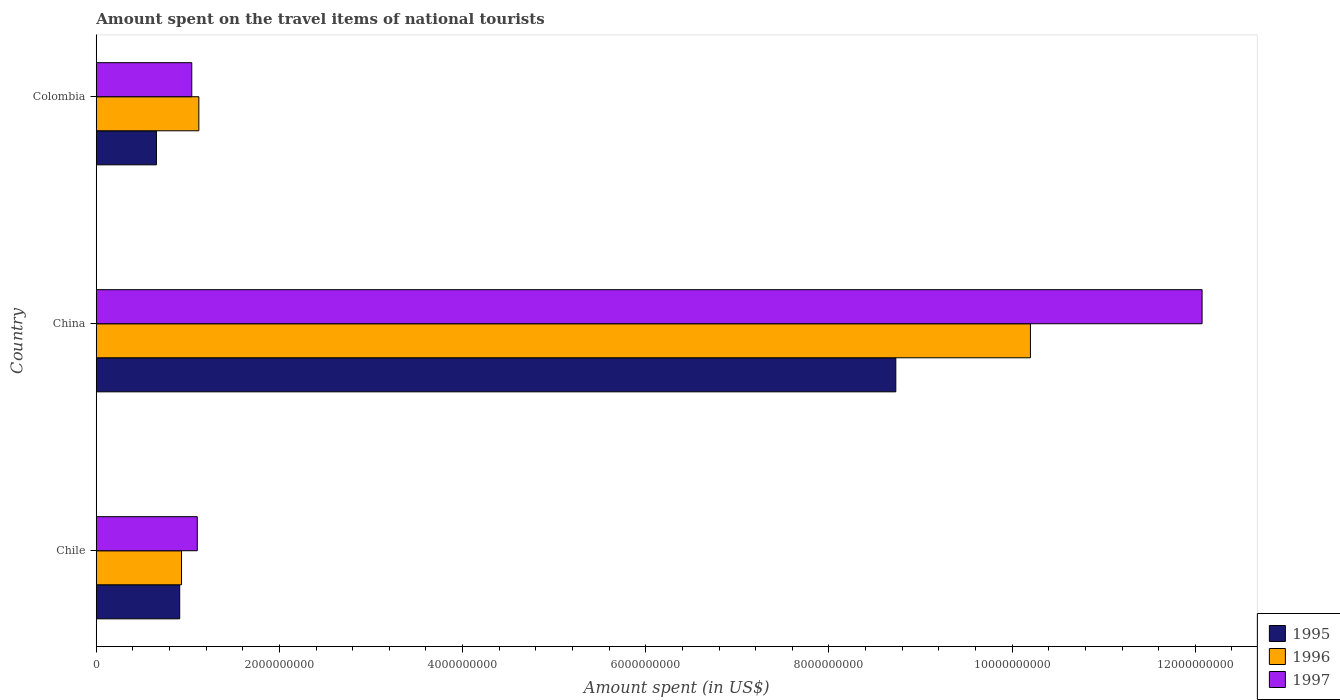Are the number of bars per tick equal to the number of legend labels?
Ensure brevity in your answer.  Yes. Are the number of bars on each tick of the Y-axis equal?
Keep it short and to the point. Yes. How many bars are there on the 3rd tick from the top?
Your answer should be compact. 3. What is the amount spent on the travel items of national tourists in 1997 in Chile?
Give a very brief answer. 1.10e+09. Across all countries, what is the maximum amount spent on the travel items of national tourists in 1995?
Offer a terse response. 8.73e+09. Across all countries, what is the minimum amount spent on the travel items of national tourists in 1995?
Offer a very short reply. 6.57e+08. In which country was the amount spent on the travel items of national tourists in 1997 maximum?
Give a very brief answer. China. In which country was the amount spent on the travel items of national tourists in 1997 minimum?
Your answer should be compact. Colombia. What is the total amount spent on the travel items of national tourists in 1996 in the graph?
Ensure brevity in your answer.  1.23e+1. What is the difference between the amount spent on the travel items of national tourists in 1997 in China and that in Colombia?
Keep it short and to the point. 1.10e+1. What is the difference between the amount spent on the travel items of national tourists in 1997 in China and the amount spent on the travel items of national tourists in 1996 in Chile?
Your response must be concise. 1.11e+1. What is the average amount spent on the travel items of national tourists in 1996 per country?
Your response must be concise. 4.08e+09. What is the difference between the amount spent on the travel items of national tourists in 1995 and amount spent on the travel items of national tourists in 1996 in China?
Keep it short and to the point. -1.47e+09. In how many countries, is the amount spent on the travel items of national tourists in 1996 greater than 12000000000 US$?
Your answer should be very brief. 0. What is the ratio of the amount spent on the travel items of national tourists in 1995 in Chile to that in Colombia?
Give a very brief answer. 1.39. Is the amount spent on the travel items of national tourists in 1997 in China less than that in Colombia?
Your response must be concise. No. Is the difference between the amount spent on the travel items of national tourists in 1995 in Chile and Colombia greater than the difference between the amount spent on the travel items of national tourists in 1996 in Chile and Colombia?
Your response must be concise. Yes. What is the difference between the highest and the second highest amount spent on the travel items of national tourists in 1996?
Provide a short and direct response. 9.08e+09. What is the difference between the highest and the lowest amount spent on the travel items of national tourists in 1995?
Keep it short and to the point. 8.07e+09. What does the 3rd bar from the top in Chile represents?
Make the answer very short. 1995. What does the 3rd bar from the bottom in Chile represents?
Make the answer very short. 1997. Is it the case that in every country, the sum of the amount spent on the travel items of national tourists in 1995 and amount spent on the travel items of national tourists in 1997 is greater than the amount spent on the travel items of national tourists in 1996?
Your response must be concise. Yes. How many countries are there in the graph?
Ensure brevity in your answer.  3. What is the difference between two consecutive major ticks on the X-axis?
Ensure brevity in your answer.  2.00e+09. Are the values on the major ticks of X-axis written in scientific E-notation?
Give a very brief answer. No. How many legend labels are there?
Your answer should be compact. 3. What is the title of the graph?
Ensure brevity in your answer.  Amount spent on the travel items of national tourists. Does "1992" appear as one of the legend labels in the graph?
Provide a succinct answer. No. What is the label or title of the X-axis?
Keep it short and to the point. Amount spent (in US$). What is the label or title of the Y-axis?
Offer a very short reply. Country. What is the Amount spent (in US$) in 1995 in Chile?
Ensure brevity in your answer.  9.11e+08. What is the Amount spent (in US$) of 1996 in Chile?
Give a very brief answer. 9.31e+08. What is the Amount spent (in US$) in 1997 in Chile?
Ensure brevity in your answer.  1.10e+09. What is the Amount spent (in US$) of 1995 in China?
Your answer should be very brief. 8.73e+09. What is the Amount spent (in US$) in 1996 in China?
Provide a short and direct response. 1.02e+1. What is the Amount spent (in US$) of 1997 in China?
Provide a short and direct response. 1.21e+1. What is the Amount spent (in US$) in 1995 in Colombia?
Offer a very short reply. 6.57e+08. What is the Amount spent (in US$) of 1996 in Colombia?
Provide a short and direct response. 1.12e+09. What is the Amount spent (in US$) in 1997 in Colombia?
Offer a very short reply. 1.04e+09. Across all countries, what is the maximum Amount spent (in US$) in 1995?
Your response must be concise. 8.73e+09. Across all countries, what is the maximum Amount spent (in US$) of 1996?
Offer a terse response. 1.02e+1. Across all countries, what is the maximum Amount spent (in US$) in 1997?
Provide a succinct answer. 1.21e+1. Across all countries, what is the minimum Amount spent (in US$) in 1995?
Your answer should be compact. 6.57e+08. Across all countries, what is the minimum Amount spent (in US$) of 1996?
Keep it short and to the point. 9.31e+08. Across all countries, what is the minimum Amount spent (in US$) of 1997?
Offer a very short reply. 1.04e+09. What is the total Amount spent (in US$) in 1995 in the graph?
Ensure brevity in your answer.  1.03e+1. What is the total Amount spent (in US$) in 1996 in the graph?
Your answer should be compact. 1.23e+1. What is the total Amount spent (in US$) of 1997 in the graph?
Provide a succinct answer. 1.42e+1. What is the difference between the Amount spent (in US$) of 1995 in Chile and that in China?
Your response must be concise. -7.82e+09. What is the difference between the Amount spent (in US$) in 1996 in Chile and that in China?
Offer a terse response. -9.27e+09. What is the difference between the Amount spent (in US$) in 1997 in Chile and that in China?
Offer a terse response. -1.10e+1. What is the difference between the Amount spent (in US$) of 1995 in Chile and that in Colombia?
Make the answer very short. 2.54e+08. What is the difference between the Amount spent (in US$) in 1996 in Chile and that in Colombia?
Offer a terse response. -1.89e+08. What is the difference between the Amount spent (in US$) of 1997 in Chile and that in Colombia?
Offer a very short reply. 6.00e+07. What is the difference between the Amount spent (in US$) of 1995 in China and that in Colombia?
Provide a short and direct response. 8.07e+09. What is the difference between the Amount spent (in US$) in 1996 in China and that in Colombia?
Provide a short and direct response. 9.08e+09. What is the difference between the Amount spent (in US$) of 1997 in China and that in Colombia?
Keep it short and to the point. 1.10e+1. What is the difference between the Amount spent (in US$) in 1995 in Chile and the Amount spent (in US$) in 1996 in China?
Ensure brevity in your answer.  -9.29e+09. What is the difference between the Amount spent (in US$) in 1995 in Chile and the Amount spent (in US$) in 1997 in China?
Give a very brief answer. -1.12e+1. What is the difference between the Amount spent (in US$) of 1996 in Chile and the Amount spent (in US$) of 1997 in China?
Offer a very short reply. -1.11e+1. What is the difference between the Amount spent (in US$) in 1995 in Chile and the Amount spent (in US$) in 1996 in Colombia?
Make the answer very short. -2.09e+08. What is the difference between the Amount spent (in US$) in 1995 in Chile and the Amount spent (in US$) in 1997 in Colombia?
Offer a terse response. -1.32e+08. What is the difference between the Amount spent (in US$) of 1996 in Chile and the Amount spent (in US$) of 1997 in Colombia?
Provide a succinct answer. -1.12e+08. What is the difference between the Amount spent (in US$) in 1995 in China and the Amount spent (in US$) in 1996 in Colombia?
Keep it short and to the point. 7.61e+09. What is the difference between the Amount spent (in US$) of 1995 in China and the Amount spent (in US$) of 1997 in Colombia?
Your response must be concise. 7.69e+09. What is the difference between the Amount spent (in US$) in 1996 in China and the Amount spent (in US$) in 1997 in Colombia?
Provide a succinct answer. 9.16e+09. What is the average Amount spent (in US$) in 1995 per country?
Make the answer very short. 3.43e+09. What is the average Amount spent (in US$) in 1996 per country?
Your response must be concise. 4.08e+09. What is the average Amount spent (in US$) in 1997 per country?
Offer a terse response. 4.74e+09. What is the difference between the Amount spent (in US$) of 1995 and Amount spent (in US$) of 1996 in Chile?
Your response must be concise. -2.00e+07. What is the difference between the Amount spent (in US$) of 1995 and Amount spent (in US$) of 1997 in Chile?
Provide a short and direct response. -1.92e+08. What is the difference between the Amount spent (in US$) in 1996 and Amount spent (in US$) in 1997 in Chile?
Offer a terse response. -1.72e+08. What is the difference between the Amount spent (in US$) in 1995 and Amount spent (in US$) in 1996 in China?
Offer a terse response. -1.47e+09. What is the difference between the Amount spent (in US$) in 1995 and Amount spent (in US$) in 1997 in China?
Ensure brevity in your answer.  -3.34e+09. What is the difference between the Amount spent (in US$) in 1996 and Amount spent (in US$) in 1997 in China?
Offer a very short reply. -1.87e+09. What is the difference between the Amount spent (in US$) in 1995 and Amount spent (in US$) in 1996 in Colombia?
Your answer should be compact. -4.63e+08. What is the difference between the Amount spent (in US$) in 1995 and Amount spent (in US$) in 1997 in Colombia?
Keep it short and to the point. -3.86e+08. What is the difference between the Amount spent (in US$) of 1996 and Amount spent (in US$) of 1997 in Colombia?
Provide a succinct answer. 7.70e+07. What is the ratio of the Amount spent (in US$) of 1995 in Chile to that in China?
Your answer should be very brief. 0.1. What is the ratio of the Amount spent (in US$) in 1996 in Chile to that in China?
Keep it short and to the point. 0.09. What is the ratio of the Amount spent (in US$) of 1997 in Chile to that in China?
Make the answer very short. 0.09. What is the ratio of the Amount spent (in US$) in 1995 in Chile to that in Colombia?
Give a very brief answer. 1.39. What is the ratio of the Amount spent (in US$) in 1996 in Chile to that in Colombia?
Make the answer very short. 0.83. What is the ratio of the Amount spent (in US$) of 1997 in Chile to that in Colombia?
Ensure brevity in your answer.  1.06. What is the ratio of the Amount spent (in US$) in 1995 in China to that in Colombia?
Your answer should be compact. 13.29. What is the ratio of the Amount spent (in US$) of 1996 in China to that in Colombia?
Your answer should be compact. 9.11. What is the ratio of the Amount spent (in US$) in 1997 in China to that in Colombia?
Make the answer very short. 11.58. What is the difference between the highest and the second highest Amount spent (in US$) of 1995?
Ensure brevity in your answer.  7.82e+09. What is the difference between the highest and the second highest Amount spent (in US$) of 1996?
Keep it short and to the point. 9.08e+09. What is the difference between the highest and the second highest Amount spent (in US$) in 1997?
Make the answer very short. 1.10e+1. What is the difference between the highest and the lowest Amount spent (in US$) of 1995?
Ensure brevity in your answer.  8.07e+09. What is the difference between the highest and the lowest Amount spent (in US$) in 1996?
Offer a very short reply. 9.27e+09. What is the difference between the highest and the lowest Amount spent (in US$) in 1997?
Your answer should be very brief. 1.10e+1. 